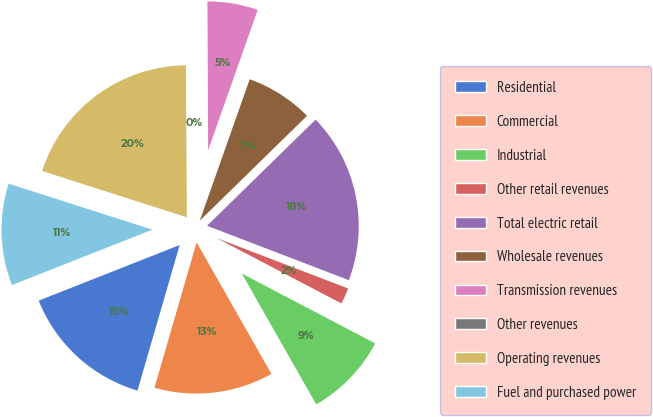Convert chart. <chart><loc_0><loc_0><loc_500><loc_500><pie_chart><fcel>Residential<fcel>Commercial<fcel>Industrial<fcel>Other retail revenues<fcel>Total electric retail<fcel>Wholesale revenues<fcel>Transmission revenues<fcel>Other revenues<fcel>Operating revenues<fcel>Fuel and purchased power<nl><fcel>14.53%<fcel>12.72%<fcel>9.09%<fcel>1.85%<fcel>18.15%<fcel>7.28%<fcel>5.47%<fcel>0.04%<fcel>19.96%<fcel>10.91%<nl></chart> 